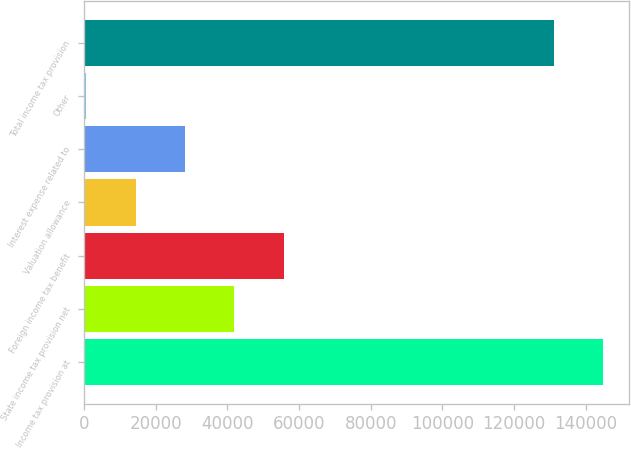Convert chart to OTSL. <chart><loc_0><loc_0><loc_500><loc_500><bar_chart><fcel>Income tax provision at<fcel>State income tax provision net<fcel>Foreign income tax benefit<fcel>Valuation allowance<fcel>Interest expense related to<fcel>Other<fcel>Total income tax provision<nl><fcel>144995<fcel>41912<fcel>55697<fcel>14342<fcel>28127<fcel>557<fcel>131210<nl></chart> 